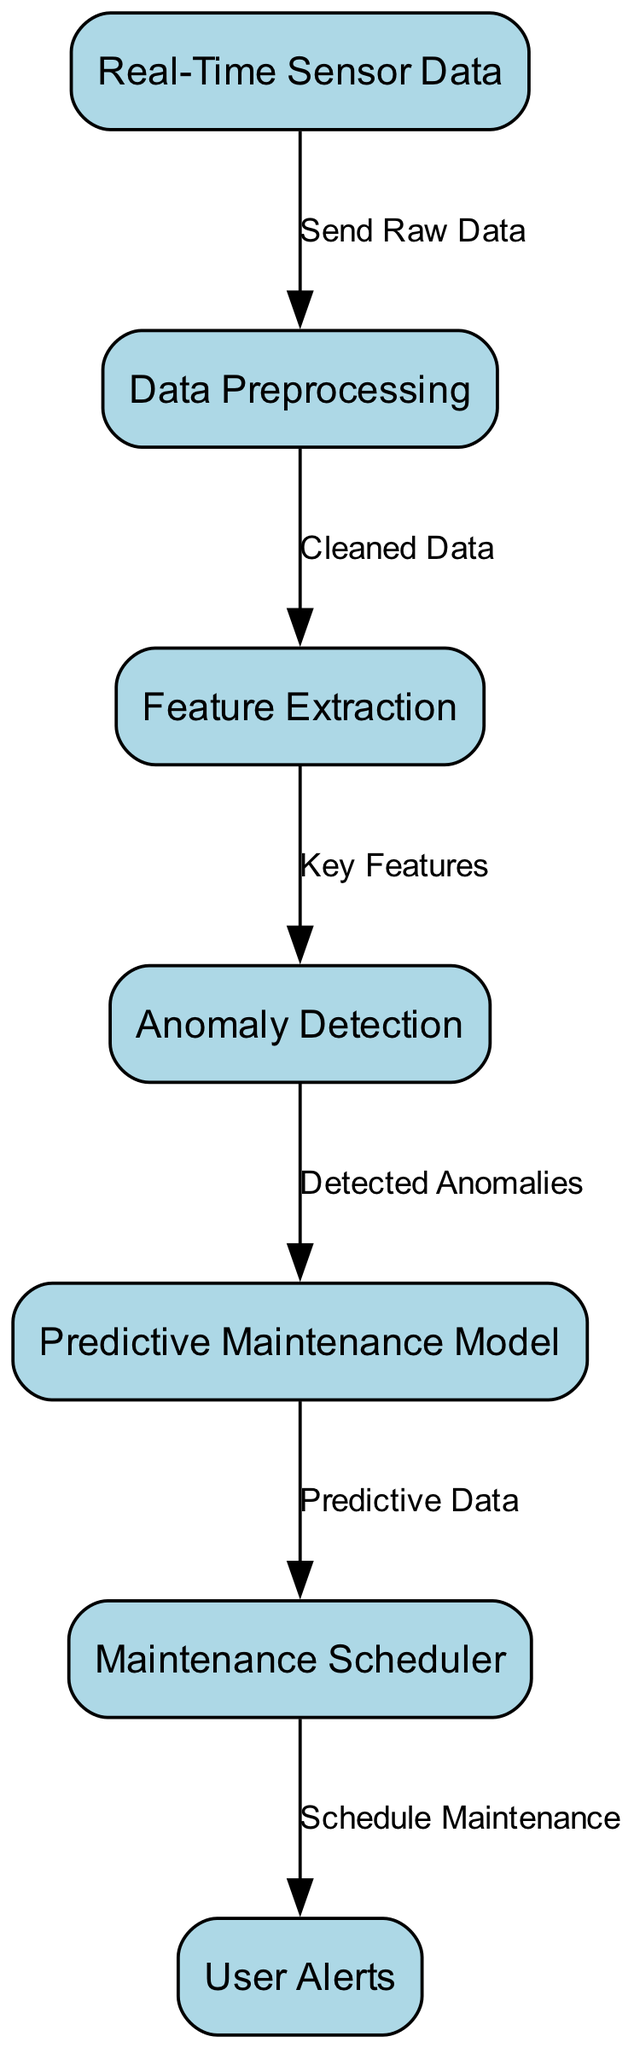What is the first node in the diagram? The first node, which represents the initial input data, is "Real-Time Sensor Data." This is where the process begins before moving to any further steps.
Answer: Real-Time Sensor Data How many edges are in the diagram? By counting each connection between the nodes, there are a total of six edges that indicate the flow from one process to another.
Answer: 6 What do the edges from "Data Preprocessing" point to? The edges from "Data Preprocessing" specifically lead to "Feature Extraction." This shows how cleaned data is passed on for further processing.
Answer: Feature Extraction What type of model is used in this process? The diagram specifies that a "Predictive Maintenance Model" is utilized. This indicates a focus on anticipating maintenance needs based on the analyzed data.
Answer: Predictive Maintenance Model Which node receives data after "Anomaly Detection"? The next node that receives data after "Anomaly Detection" is "Predictive Maintenance Model." It utilizes detected anomalies to improve maintenance scheduling.
Answer: Predictive Maintenance Model How is the alert feature triggered in this diagram? The "Maintenance Scheduler" is responsible for scheduling maintenance based on "Predictive Data," which in turn leads to triggering user alerts.
Answer: User Alerts What is the purpose of the "Feature Extraction" node? The purpose of the "Feature Extraction" node is to analyze and identify key features from the cleaned data that are necessary for further processing in the diagram.
Answer: Analyze key features What does the edge labeled "Detected Anomalies" connect to? The edge labeled "Detected Anomalies" connects the "Anomaly Detection" node to the "Predictive Maintenance Model," showing the flow of insights regarding any anomalies found.
Answer: Predictive Maintenance Model What indicates the flow of information in the diagram? The edges between the nodes indicate the flow of information, showing how each process sends its output to the next step in the predictive maintenance scheduling.
Answer: Edges 